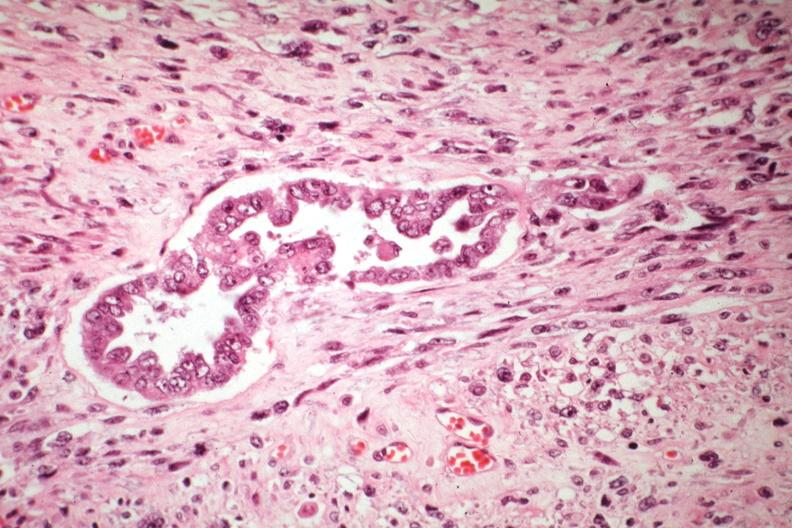what is present?
Answer the question using a single word or phrase. Female reproductive 